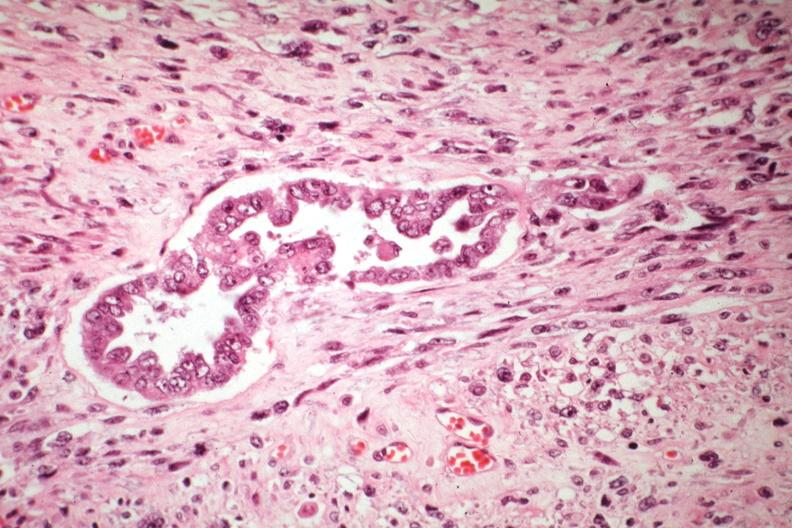what is present?
Answer the question using a single word or phrase. Female reproductive 